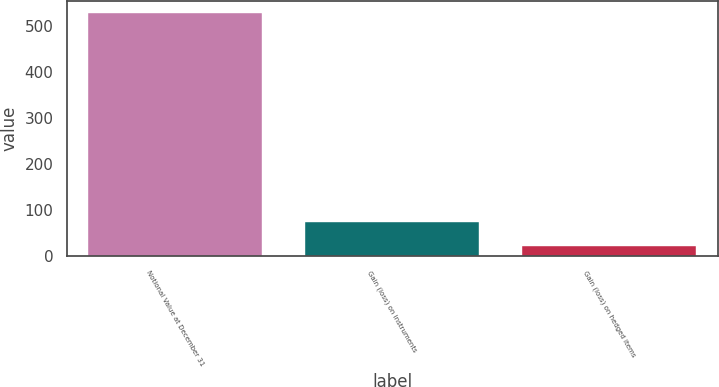Convert chart to OTSL. <chart><loc_0><loc_0><loc_500><loc_500><bar_chart><fcel>Notional Value at December 31<fcel>Gain (loss) on instruments<fcel>Gain (loss) on hedged items<nl><fcel>529<fcel>73.6<fcel>23<nl></chart> 